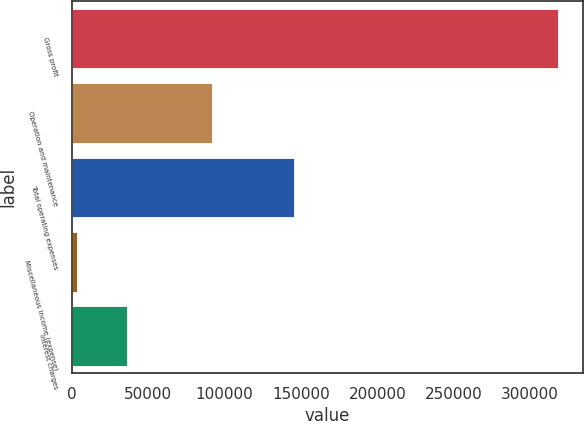Convert chart to OTSL. <chart><loc_0><loc_0><loc_500><loc_500><bar_chart><fcel>Gross profit<fcel>Operation and maintenance<fcel>Total operating expenses<fcel>Miscellaneous income (expense)<fcel>Interest charges<nl><fcel>318459<fcel>91466<fcel>145640<fcel>3181<fcel>36280<nl></chart> 